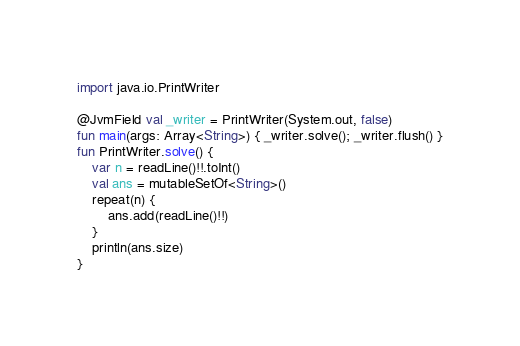Convert code to text. <code><loc_0><loc_0><loc_500><loc_500><_Kotlin_>import java.io.PrintWriter

@JvmField val _writer = PrintWriter(System.out, false)
fun main(args: Array<String>) { _writer.solve(); _writer.flush() }
fun PrintWriter.solve() {
    var n = readLine()!!.toInt()
    val ans = mutableSetOf<String>()
    repeat(n) {
        ans.add(readLine()!!)
    }
    println(ans.size)
}
</code> 